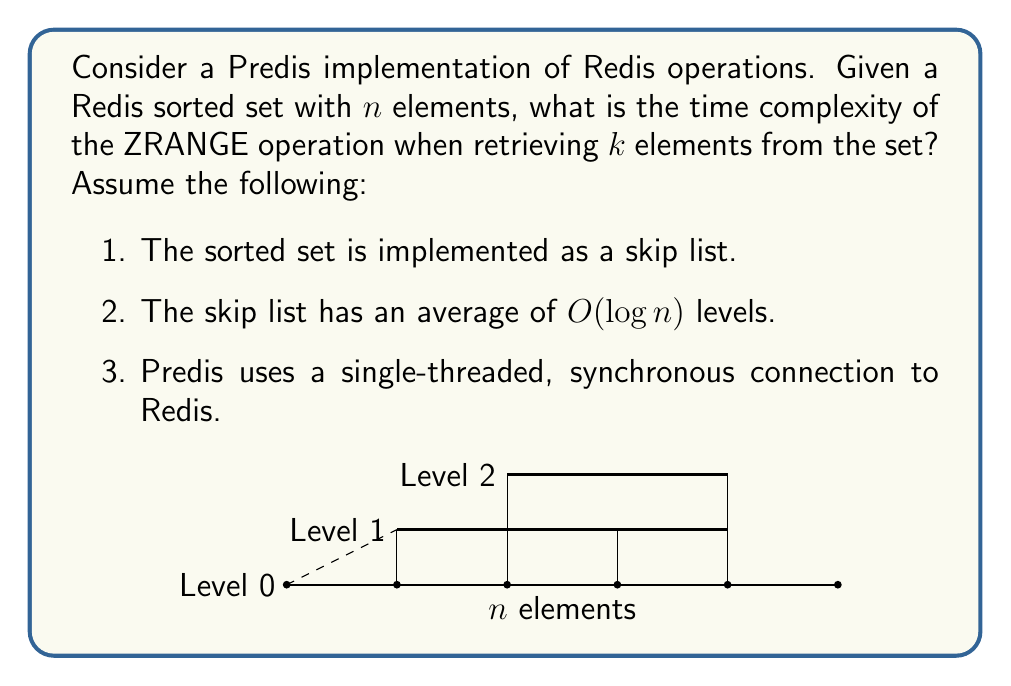Teach me how to tackle this problem. To analyze the time complexity of the ZRANGE operation in Predis, we need to consider the following steps:

1. Connection overhead:
   - Predis establishes a connection to Redis, which is typically $O(1)$ for a single-threaded, synchronous connection.

2. Locating the start element:
   - In a skip list with $O(\log n)$ levels, finding the start element takes $O(\log n)$ time.

3. Retrieving $k$ elements:
   - Once the start element is found, retrieving $k$ elements involves traversing $k$ nodes at the bottom level of the skip list.
   - This operation takes $O(k)$ time.

4. Serialization and network transfer:
   - Predis needs to serialize the retrieved elements and send them over the network.
   - This operation is proportional to the number of elements retrieved, so it's $O(k)$.

5. Client-side processing:
   - Predis needs to deserialize the received data, which is also $O(k)$.

Combining these steps, we get:

$$O(1) + O(\log n) + O(k) + O(k) + O(k) = O(\log n + k)$$

The dominant terms are $O(\log n)$ for finding the start element and $O(k)$ for retrieving and processing $k$ elements.

It's important to note that this analysis assumes that $k$ is not significantly larger than $n$. In the worst case, where $k = n$, the time complexity would simplify to $O(n)$.
Answer: $O(\log n + k)$ 